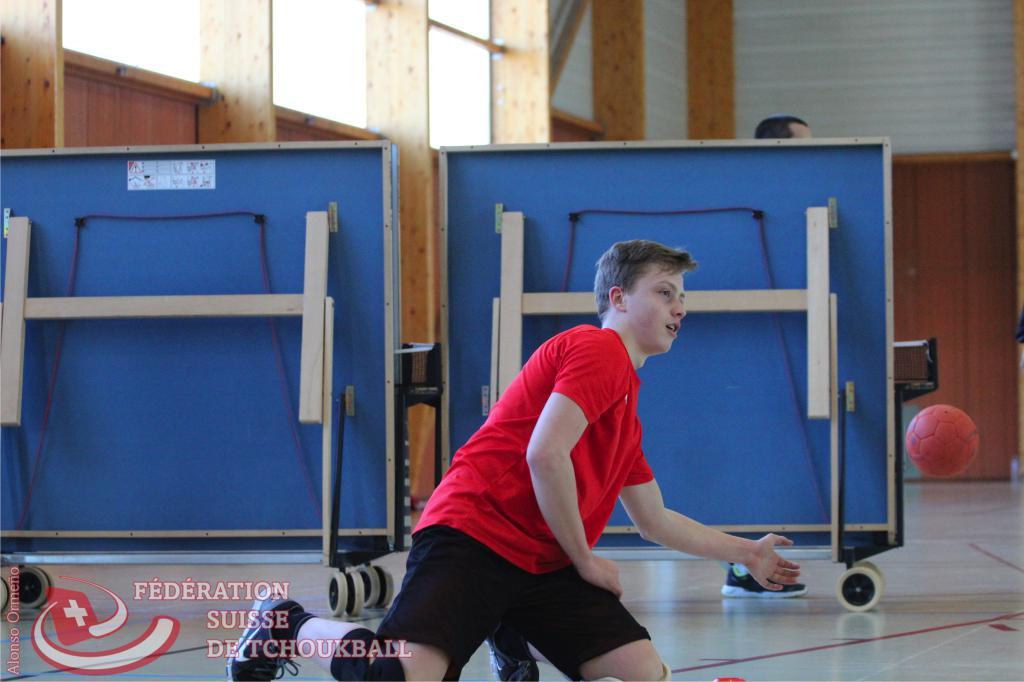What type of federation is it?
Provide a succinct answer. Suisse detchoukball. What is the man's name on the left side of the photo?
Your response must be concise. Alonso ormeno. 